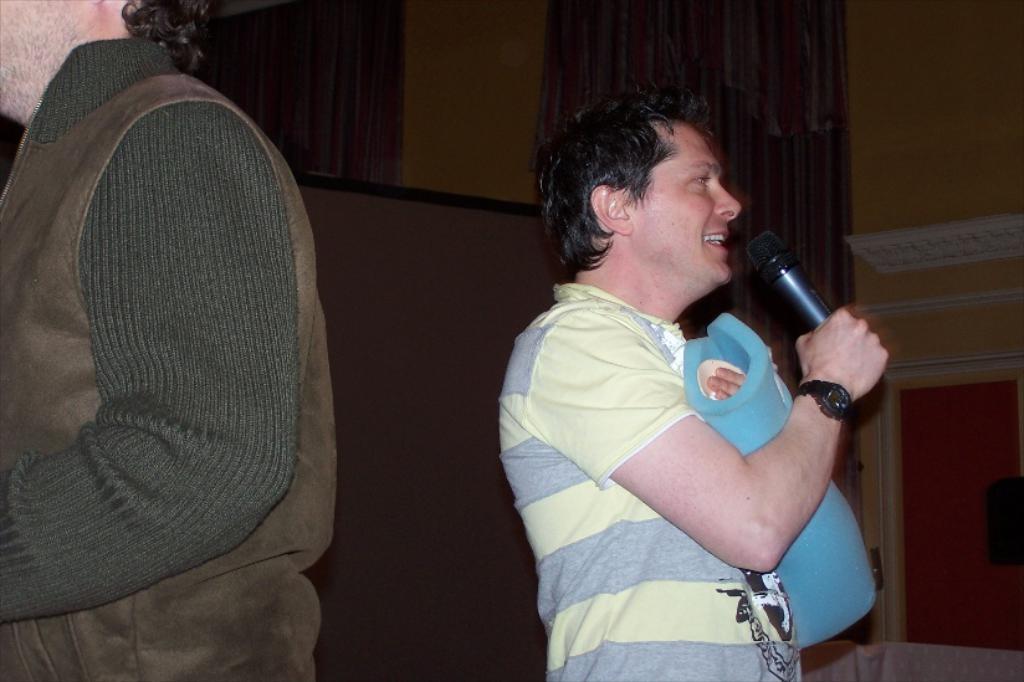How would you summarize this image in a sentence or two? In this picture we can see a man holding a mike in his hand and talking. At the left side of the picture we can see other man. On the background there is a wall. 